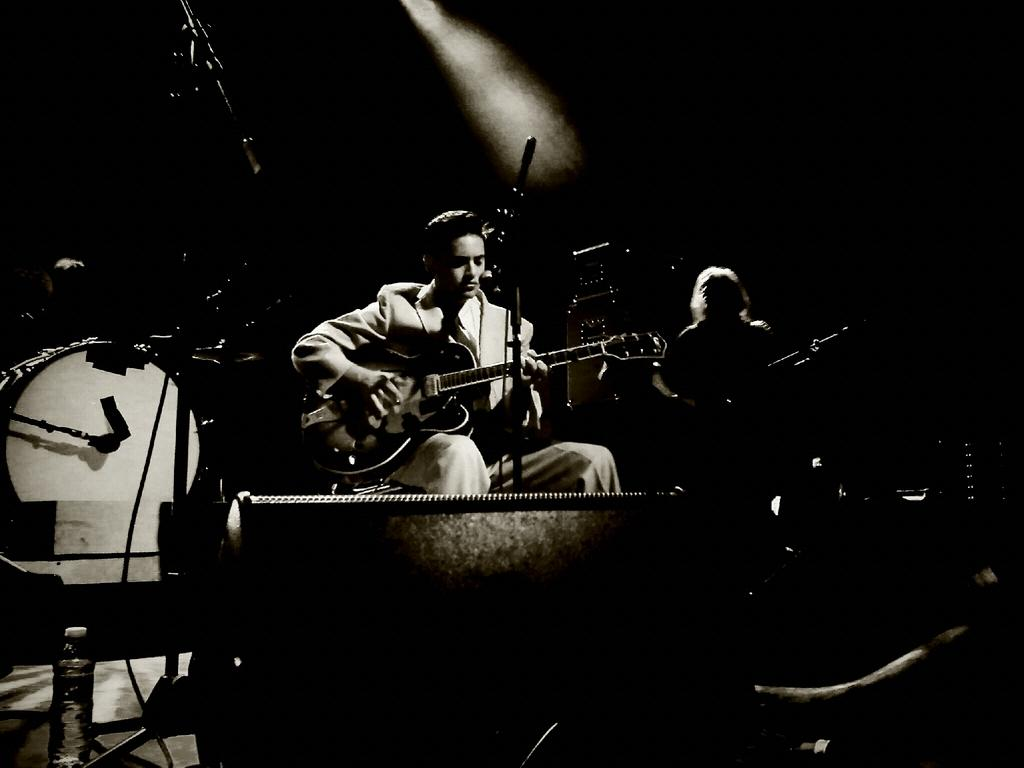What is the man in the image doing? The man is seated and playing a guitar. What object is present in the image that is commonly used for amplifying sound? There is a microphone in the image. What is the other man in the image doing? The other man is seated and playing an instrument. What type of percussion instrument can be seen in the image? There are drums visible in the image. What language is the man singing in the image? There is no indication in the image that the man is singing, so it cannot be determined what language he might be singing in. 